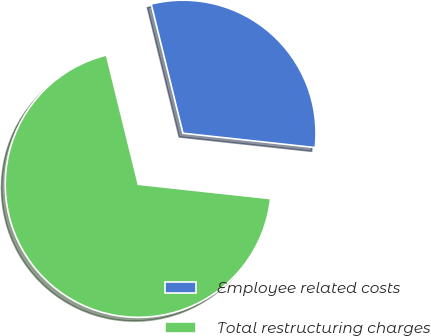<chart> <loc_0><loc_0><loc_500><loc_500><pie_chart><fcel>Employee related costs<fcel>Total restructuring charges<nl><fcel>30.56%<fcel>69.44%<nl></chart> 